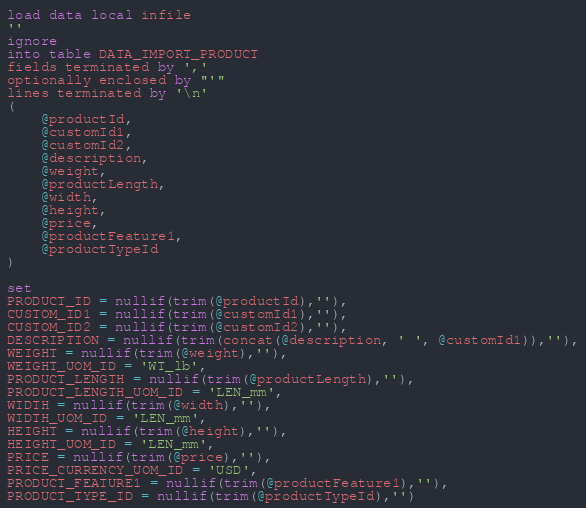<code> <loc_0><loc_0><loc_500><loc_500><_SQL_>load data local infile
''
ignore
into table DATA_IMPORT_PRODUCT
fields terminated by ','
optionally enclosed by "'"
lines terminated by '\n'
(
    @productId,
    @customId1,
    @customId2,
    @description,
    @weight,
    @productLength,
    @width,
    @height,
    @price,
    @productFeature1,
    @productTypeId
)

set
PRODUCT_ID = nullif(trim(@productId),''),
CUSTOM_ID1 = nullif(trim(@customId1),''),
CUSTOM_ID2 = nullif(trim(@customId2),''),
DESCRIPTION = nullif(trim(concat(@description, ' ', @customId1)),''),
WEIGHT = nullif(trim(@weight),''),
WEIGHT_UOM_ID = 'WT_lb',
PRODUCT_LENGTH = nullif(trim(@productLength),''),
PRODUCT_LENGTH_UOM_ID = 'LEN_mm',
WIDTH = nullif(trim(@width),''),
WIDTH_UOM_ID = 'LEN_mm',
HEIGHT = nullif(trim(@height),''),
HEIGHT_UOM_ID = 'LEN_mm',
PRICE = nullif(trim(@price),''),
PRICE_CURRENCY_UOM_ID = 'USD',
PRODUCT_FEATURE1 = nullif(trim(@productFeature1),''),
PRODUCT_TYPE_ID = nullif(trim(@productTypeId),'')
</code> 